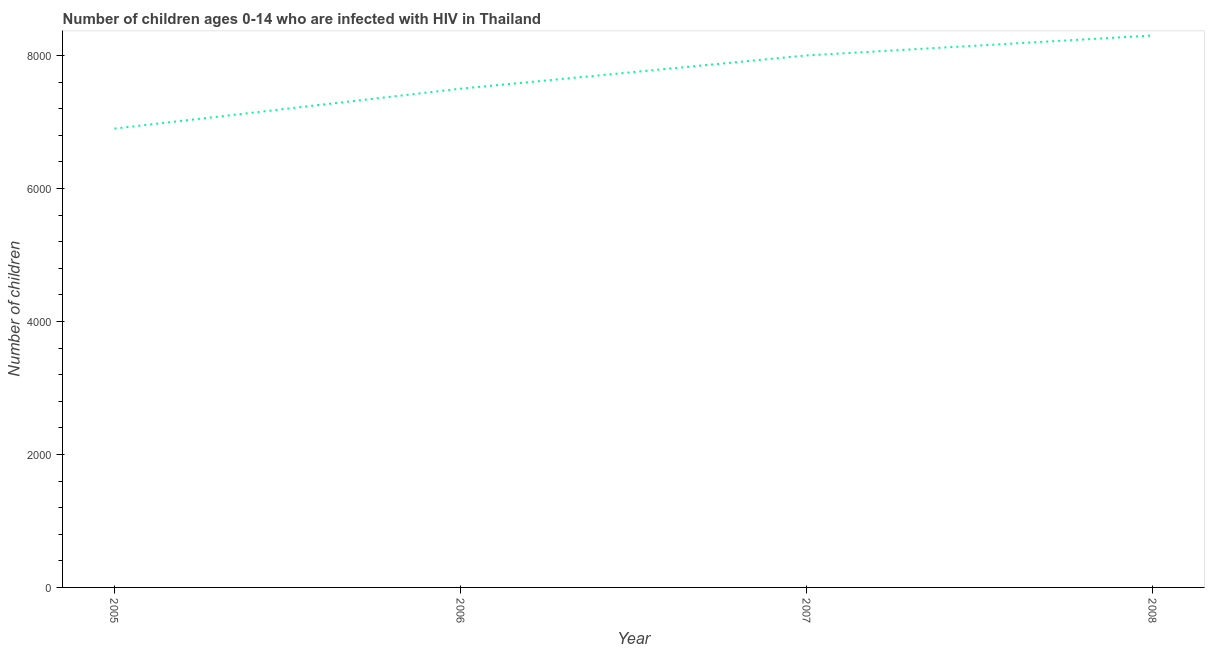What is the number of children living with hiv in 2008?
Ensure brevity in your answer.  8300. Across all years, what is the maximum number of children living with hiv?
Give a very brief answer. 8300. Across all years, what is the minimum number of children living with hiv?
Provide a succinct answer. 6900. What is the sum of the number of children living with hiv?
Provide a succinct answer. 3.07e+04. What is the difference between the number of children living with hiv in 2006 and 2007?
Provide a short and direct response. -500. What is the average number of children living with hiv per year?
Your response must be concise. 7675. What is the median number of children living with hiv?
Your response must be concise. 7750. Do a majority of the years between 2005 and 2007 (inclusive) have number of children living with hiv greater than 1200 ?
Your response must be concise. Yes. Is the difference between the number of children living with hiv in 2005 and 2007 greater than the difference between any two years?
Your response must be concise. No. What is the difference between the highest and the second highest number of children living with hiv?
Your answer should be very brief. 300. Is the sum of the number of children living with hiv in 2006 and 2007 greater than the maximum number of children living with hiv across all years?
Your answer should be compact. Yes. What is the difference between the highest and the lowest number of children living with hiv?
Your answer should be very brief. 1400. How many lines are there?
Give a very brief answer. 1. How many years are there in the graph?
Provide a succinct answer. 4. What is the difference between two consecutive major ticks on the Y-axis?
Provide a short and direct response. 2000. Are the values on the major ticks of Y-axis written in scientific E-notation?
Give a very brief answer. No. Does the graph contain grids?
Offer a terse response. No. What is the title of the graph?
Offer a very short reply. Number of children ages 0-14 who are infected with HIV in Thailand. What is the label or title of the X-axis?
Your response must be concise. Year. What is the label or title of the Y-axis?
Make the answer very short. Number of children. What is the Number of children of 2005?
Provide a succinct answer. 6900. What is the Number of children in 2006?
Make the answer very short. 7500. What is the Number of children in 2007?
Your response must be concise. 8000. What is the Number of children in 2008?
Keep it short and to the point. 8300. What is the difference between the Number of children in 2005 and 2006?
Your response must be concise. -600. What is the difference between the Number of children in 2005 and 2007?
Your answer should be very brief. -1100. What is the difference between the Number of children in 2005 and 2008?
Offer a terse response. -1400. What is the difference between the Number of children in 2006 and 2007?
Your answer should be very brief. -500. What is the difference between the Number of children in 2006 and 2008?
Your answer should be very brief. -800. What is the difference between the Number of children in 2007 and 2008?
Keep it short and to the point. -300. What is the ratio of the Number of children in 2005 to that in 2007?
Provide a succinct answer. 0.86. What is the ratio of the Number of children in 2005 to that in 2008?
Your answer should be compact. 0.83. What is the ratio of the Number of children in 2006 to that in 2007?
Provide a succinct answer. 0.94. What is the ratio of the Number of children in 2006 to that in 2008?
Give a very brief answer. 0.9. 